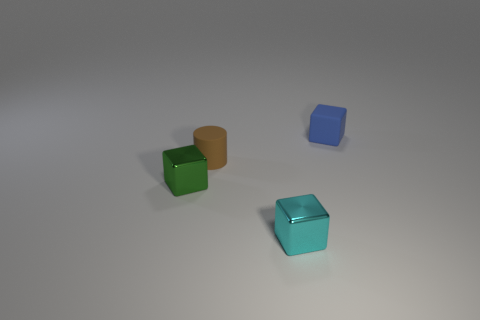Add 1 small yellow matte objects. How many objects exist? 5 Subtract all cylinders. How many objects are left? 3 Add 1 brown objects. How many brown objects exist? 2 Subtract 0 yellow spheres. How many objects are left? 4 Subtract all tiny matte blocks. Subtract all small metal objects. How many objects are left? 1 Add 1 blue matte things. How many blue matte things are left? 2 